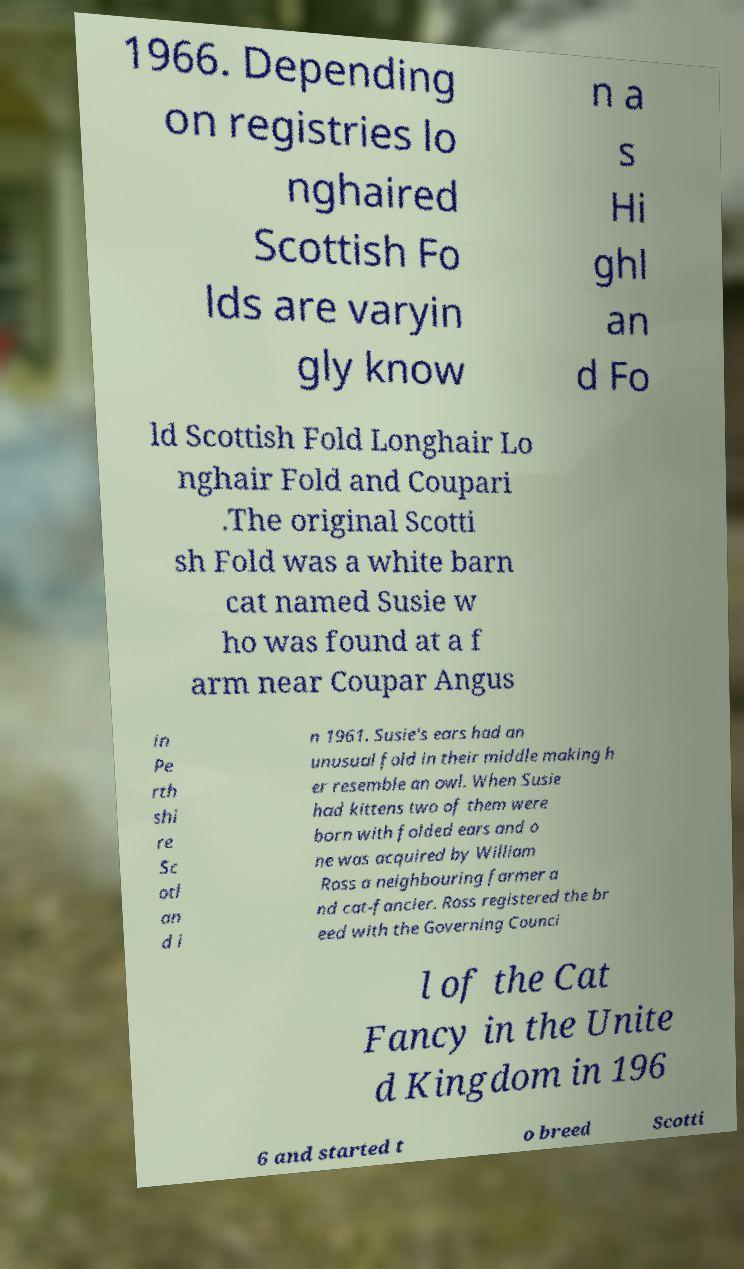Please identify and transcribe the text found in this image. 1966. Depending on registries lo nghaired Scottish Fo lds are varyin gly know n a s Hi ghl an d Fo ld Scottish Fold Longhair Lo nghair Fold and Coupari .The original Scotti sh Fold was a white barn cat named Susie w ho was found at a f arm near Coupar Angus in Pe rth shi re Sc otl an d i n 1961. Susie's ears had an unusual fold in their middle making h er resemble an owl. When Susie had kittens two of them were born with folded ears and o ne was acquired by William Ross a neighbouring farmer a nd cat-fancier. Ross registered the br eed with the Governing Counci l of the Cat Fancy in the Unite d Kingdom in 196 6 and started t o breed Scotti 